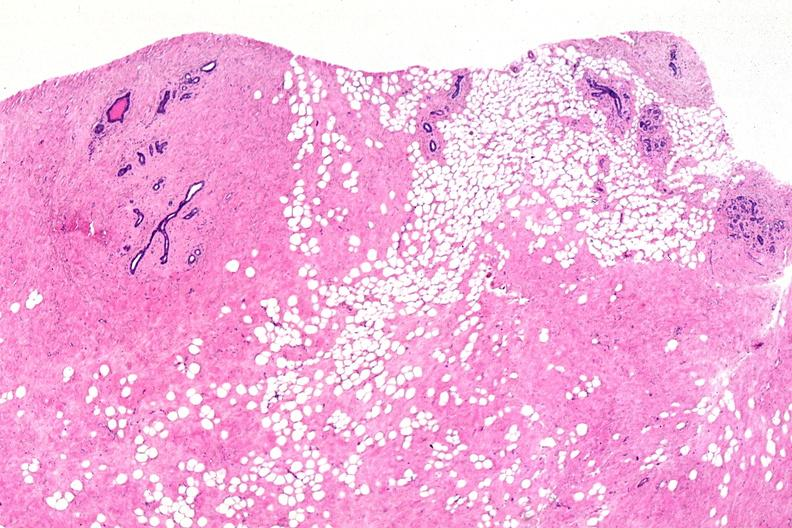s abdomen present?
Answer the question using a single word or phrase. No 